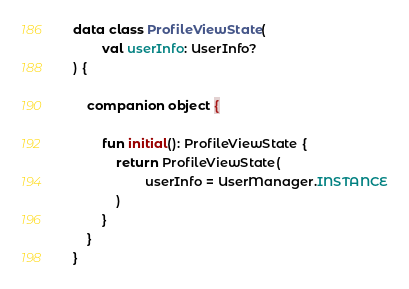Convert code to text. <code><loc_0><loc_0><loc_500><loc_500><_Kotlin_>data class ProfileViewState(
        val userInfo: UserInfo?
) {

    companion object {

        fun initial(): ProfileViewState {
            return ProfileViewState(
                    userInfo = UserManager.INSTANCE
            )
        }
    }
}</code> 